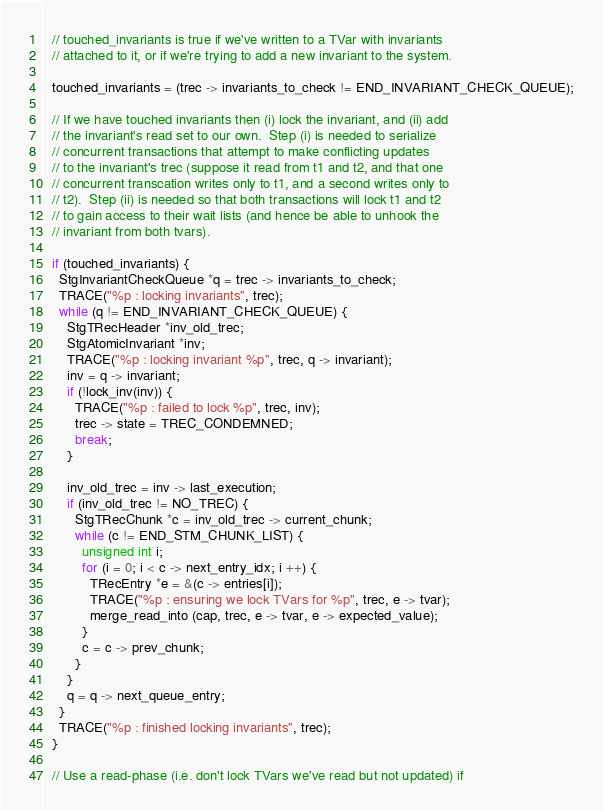Convert code to text. <code><loc_0><loc_0><loc_500><loc_500><_C_>  // touched_invariants is true if we've written to a TVar with invariants
  // attached to it, or if we're trying to add a new invariant to the system.

  touched_invariants = (trec -> invariants_to_check != END_INVARIANT_CHECK_QUEUE);

  // If we have touched invariants then (i) lock the invariant, and (ii) add
  // the invariant's read set to our own.  Step (i) is needed to serialize
  // concurrent transactions that attempt to make conflicting updates
  // to the invariant's trec (suppose it read from t1 and t2, and that one
  // concurrent transcation writes only to t1, and a second writes only to
  // t2).  Step (ii) is needed so that both transactions will lock t1 and t2
  // to gain access to their wait lists (and hence be able to unhook the
  // invariant from both tvars).

  if (touched_invariants) {
    StgInvariantCheckQueue *q = trec -> invariants_to_check;
    TRACE("%p : locking invariants", trec);
    while (q != END_INVARIANT_CHECK_QUEUE) {
      StgTRecHeader *inv_old_trec;
      StgAtomicInvariant *inv;
      TRACE("%p : locking invariant %p", trec, q -> invariant);
      inv = q -> invariant;
      if (!lock_inv(inv)) {
        TRACE("%p : failed to lock %p", trec, inv);
        trec -> state = TREC_CONDEMNED;
        break;
      }

      inv_old_trec = inv -> last_execution;
      if (inv_old_trec != NO_TREC) {
        StgTRecChunk *c = inv_old_trec -> current_chunk;
        while (c != END_STM_CHUNK_LIST) {
          unsigned int i;
          for (i = 0; i < c -> next_entry_idx; i ++) {
            TRecEntry *e = &(c -> entries[i]);
            TRACE("%p : ensuring we lock TVars for %p", trec, e -> tvar);
            merge_read_into (cap, trec, e -> tvar, e -> expected_value);
          }
          c = c -> prev_chunk;
        }
      }
      q = q -> next_queue_entry;
    }
    TRACE("%p : finished locking invariants", trec);
  }

  // Use a read-phase (i.e. don't lock TVars we've read but not updated) if</code> 